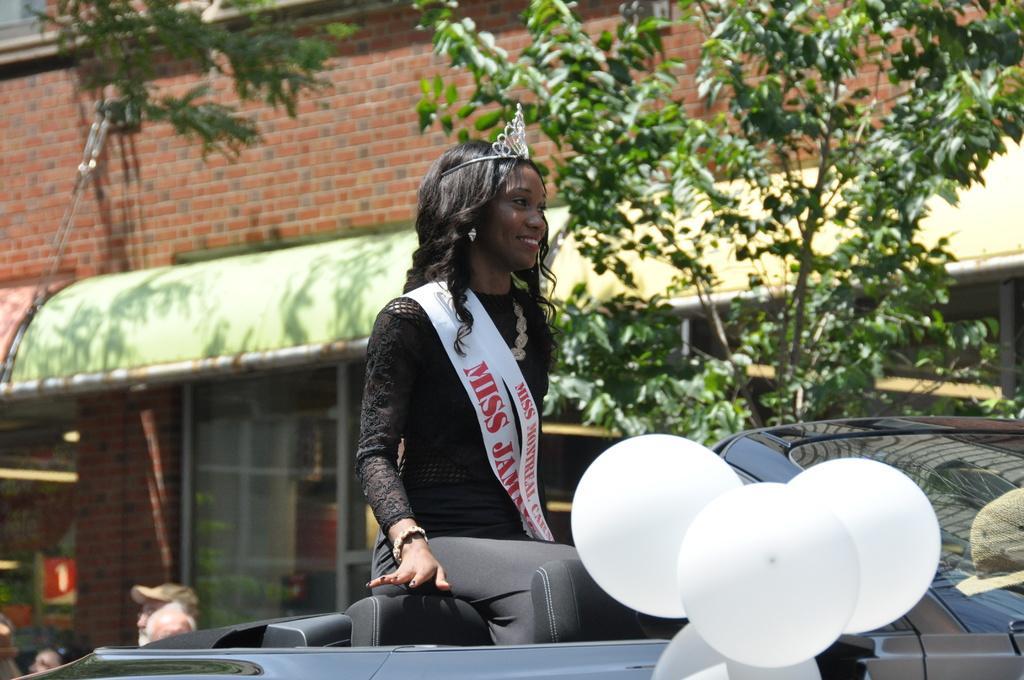Please provide a concise description of this image. In this image I can see a woman is sitting on the car, she wore black color top. On the right side there are balloons to this vehicle, at the top there are trees and a brick wall. She wore crown. 